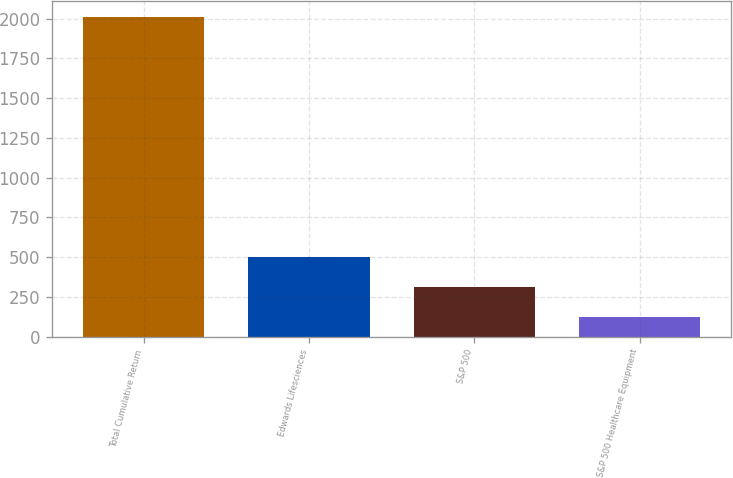Convert chart to OTSL. <chart><loc_0><loc_0><loc_500><loc_500><bar_chart><fcel>Total Cumulative Return<fcel>Edwards Lifesciences<fcel>S&P 500<fcel>S&P 500 Healthcare Equipment<nl><fcel>2011<fcel>500.89<fcel>312.13<fcel>123.37<nl></chart> 